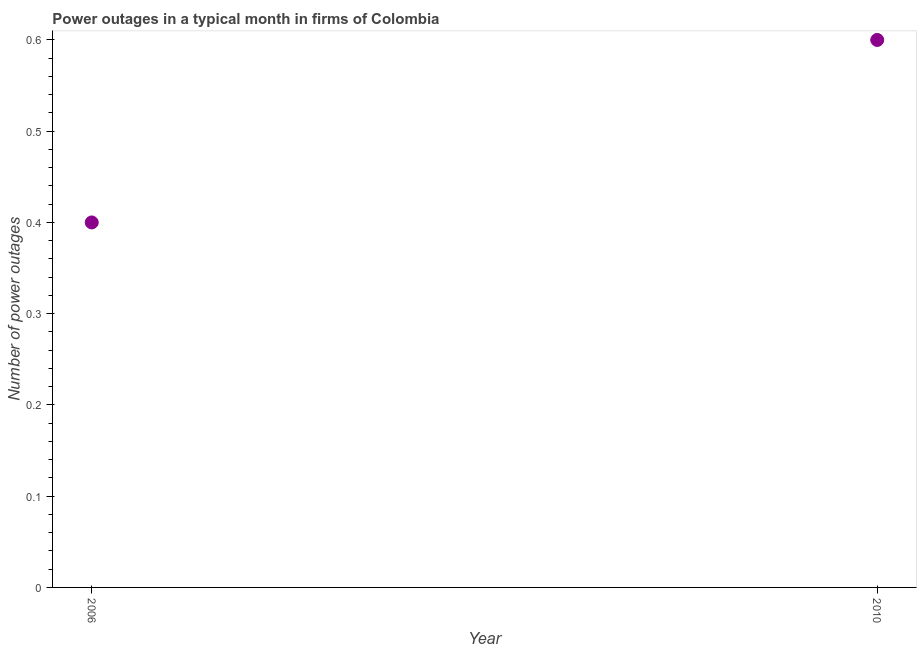What is the number of power outages in 2010?
Offer a very short reply. 0.6. In which year was the number of power outages maximum?
Give a very brief answer. 2010. What is the sum of the number of power outages?
Give a very brief answer. 1. What is the difference between the number of power outages in 2006 and 2010?
Offer a very short reply. -0.2. What is the median number of power outages?
Offer a very short reply. 0.5. In how many years, is the number of power outages greater than 0.24000000000000002 ?
Give a very brief answer. 2. Do a majority of the years between 2006 and 2010 (inclusive) have number of power outages greater than 0.46 ?
Give a very brief answer. No. What is the ratio of the number of power outages in 2006 to that in 2010?
Keep it short and to the point. 0.67. Does the number of power outages monotonically increase over the years?
Make the answer very short. Yes. How many dotlines are there?
Offer a very short reply. 1. How many years are there in the graph?
Provide a short and direct response. 2. What is the difference between two consecutive major ticks on the Y-axis?
Your answer should be compact. 0.1. Are the values on the major ticks of Y-axis written in scientific E-notation?
Give a very brief answer. No. Does the graph contain any zero values?
Make the answer very short. No. What is the title of the graph?
Keep it short and to the point. Power outages in a typical month in firms of Colombia. What is the label or title of the X-axis?
Provide a short and direct response. Year. What is the label or title of the Y-axis?
Provide a succinct answer. Number of power outages. What is the Number of power outages in 2006?
Offer a terse response. 0.4. What is the ratio of the Number of power outages in 2006 to that in 2010?
Your answer should be very brief. 0.67. 